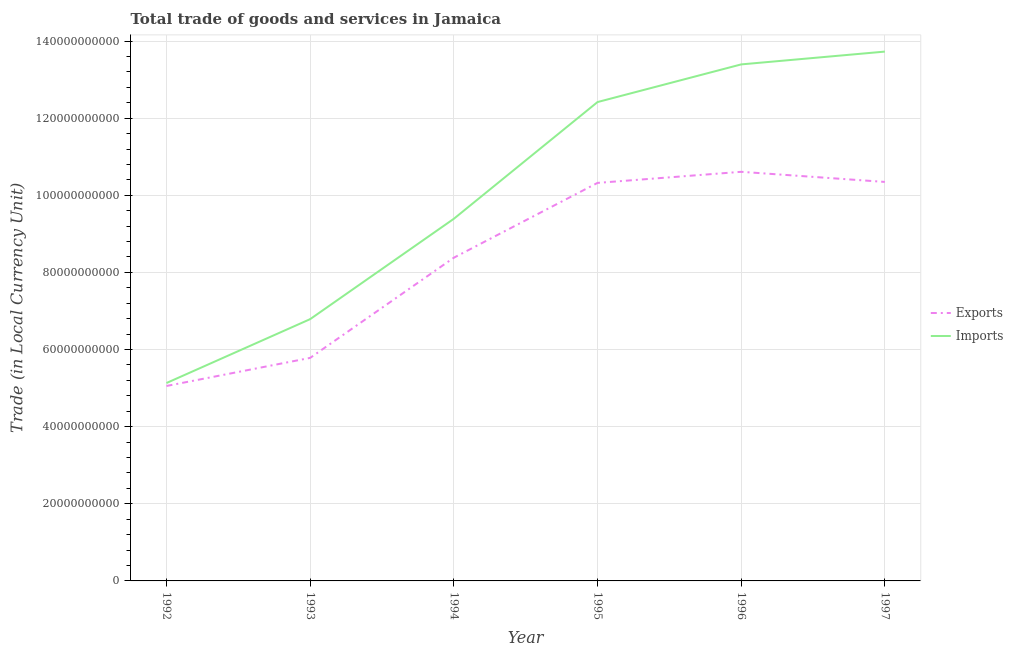How many different coloured lines are there?
Keep it short and to the point. 2. What is the export of goods and services in 1992?
Make the answer very short. 5.06e+1. Across all years, what is the maximum export of goods and services?
Make the answer very short. 1.06e+11. Across all years, what is the minimum imports of goods and services?
Keep it short and to the point. 5.13e+1. What is the total export of goods and services in the graph?
Your response must be concise. 5.05e+11. What is the difference between the export of goods and services in 1994 and that in 1995?
Offer a very short reply. -1.94e+1. What is the difference between the imports of goods and services in 1996 and the export of goods and services in 1992?
Your response must be concise. 8.34e+1. What is the average imports of goods and services per year?
Your response must be concise. 1.01e+11. In the year 1997, what is the difference between the export of goods and services and imports of goods and services?
Ensure brevity in your answer.  -3.38e+1. In how many years, is the imports of goods and services greater than 56000000000 LCU?
Keep it short and to the point. 5. What is the ratio of the export of goods and services in 1992 to that in 1997?
Your answer should be compact. 0.49. Is the export of goods and services in 1993 less than that in 1994?
Your answer should be very brief. Yes. Is the difference between the export of goods and services in 1995 and 1996 greater than the difference between the imports of goods and services in 1995 and 1996?
Make the answer very short. Yes. What is the difference between the highest and the second highest export of goods and services?
Give a very brief answer. 2.62e+09. What is the difference between the highest and the lowest export of goods and services?
Your response must be concise. 5.55e+1. Does the export of goods and services monotonically increase over the years?
Offer a very short reply. No. Is the export of goods and services strictly less than the imports of goods and services over the years?
Your answer should be very brief. Yes. How many lines are there?
Give a very brief answer. 2. Does the graph contain grids?
Your response must be concise. Yes. How many legend labels are there?
Offer a very short reply. 2. What is the title of the graph?
Your answer should be very brief. Total trade of goods and services in Jamaica. What is the label or title of the X-axis?
Offer a terse response. Year. What is the label or title of the Y-axis?
Your answer should be very brief. Trade (in Local Currency Unit). What is the Trade (in Local Currency Unit) in Exports in 1992?
Your answer should be very brief. 5.06e+1. What is the Trade (in Local Currency Unit) in Imports in 1992?
Provide a succinct answer. 5.13e+1. What is the Trade (in Local Currency Unit) in Exports in 1993?
Keep it short and to the point. 5.78e+1. What is the Trade (in Local Currency Unit) in Imports in 1993?
Make the answer very short. 6.79e+1. What is the Trade (in Local Currency Unit) in Exports in 1994?
Keep it short and to the point. 8.38e+1. What is the Trade (in Local Currency Unit) in Imports in 1994?
Make the answer very short. 9.39e+1. What is the Trade (in Local Currency Unit) in Exports in 1995?
Give a very brief answer. 1.03e+11. What is the Trade (in Local Currency Unit) of Imports in 1995?
Keep it short and to the point. 1.24e+11. What is the Trade (in Local Currency Unit) of Exports in 1996?
Give a very brief answer. 1.06e+11. What is the Trade (in Local Currency Unit) of Imports in 1996?
Ensure brevity in your answer.  1.34e+11. What is the Trade (in Local Currency Unit) of Exports in 1997?
Provide a succinct answer. 1.03e+11. What is the Trade (in Local Currency Unit) of Imports in 1997?
Your answer should be compact. 1.37e+11. Across all years, what is the maximum Trade (in Local Currency Unit) of Exports?
Make the answer very short. 1.06e+11. Across all years, what is the maximum Trade (in Local Currency Unit) of Imports?
Ensure brevity in your answer.  1.37e+11. Across all years, what is the minimum Trade (in Local Currency Unit) in Exports?
Provide a succinct answer. 5.06e+1. Across all years, what is the minimum Trade (in Local Currency Unit) of Imports?
Ensure brevity in your answer.  5.13e+1. What is the total Trade (in Local Currency Unit) of Exports in the graph?
Provide a succinct answer. 5.05e+11. What is the total Trade (in Local Currency Unit) in Imports in the graph?
Provide a short and direct response. 6.08e+11. What is the difference between the Trade (in Local Currency Unit) of Exports in 1992 and that in 1993?
Your answer should be compact. -7.28e+09. What is the difference between the Trade (in Local Currency Unit) of Imports in 1992 and that in 1993?
Your answer should be very brief. -1.66e+1. What is the difference between the Trade (in Local Currency Unit) in Exports in 1992 and that in 1994?
Keep it short and to the point. -3.33e+1. What is the difference between the Trade (in Local Currency Unit) in Imports in 1992 and that in 1994?
Provide a succinct answer. -4.26e+1. What is the difference between the Trade (in Local Currency Unit) in Exports in 1992 and that in 1995?
Your answer should be very brief. -5.27e+1. What is the difference between the Trade (in Local Currency Unit) of Imports in 1992 and that in 1995?
Ensure brevity in your answer.  -7.29e+1. What is the difference between the Trade (in Local Currency Unit) in Exports in 1992 and that in 1996?
Provide a short and direct response. -5.55e+1. What is the difference between the Trade (in Local Currency Unit) of Imports in 1992 and that in 1996?
Your response must be concise. -8.26e+1. What is the difference between the Trade (in Local Currency Unit) of Exports in 1992 and that in 1997?
Your answer should be very brief. -5.29e+1. What is the difference between the Trade (in Local Currency Unit) in Imports in 1992 and that in 1997?
Your response must be concise. -8.59e+1. What is the difference between the Trade (in Local Currency Unit) in Exports in 1993 and that in 1994?
Ensure brevity in your answer.  -2.60e+1. What is the difference between the Trade (in Local Currency Unit) of Imports in 1993 and that in 1994?
Your answer should be very brief. -2.60e+1. What is the difference between the Trade (in Local Currency Unit) of Exports in 1993 and that in 1995?
Offer a very short reply. -4.54e+1. What is the difference between the Trade (in Local Currency Unit) of Imports in 1993 and that in 1995?
Offer a terse response. -5.63e+1. What is the difference between the Trade (in Local Currency Unit) of Exports in 1993 and that in 1996?
Offer a very short reply. -4.83e+1. What is the difference between the Trade (in Local Currency Unit) in Imports in 1993 and that in 1996?
Ensure brevity in your answer.  -6.61e+1. What is the difference between the Trade (in Local Currency Unit) of Exports in 1993 and that in 1997?
Your answer should be very brief. -4.56e+1. What is the difference between the Trade (in Local Currency Unit) of Imports in 1993 and that in 1997?
Make the answer very short. -6.94e+1. What is the difference between the Trade (in Local Currency Unit) in Exports in 1994 and that in 1995?
Your answer should be very brief. -1.94e+1. What is the difference between the Trade (in Local Currency Unit) of Imports in 1994 and that in 1995?
Ensure brevity in your answer.  -3.03e+1. What is the difference between the Trade (in Local Currency Unit) in Exports in 1994 and that in 1996?
Your answer should be compact. -2.23e+1. What is the difference between the Trade (in Local Currency Unit) in Imports in 1994 and that in 1996?
Give a very brief answer. -4.00e+1. What is the difference between the Trade (in Local Currency Unit) of Exports in 1994 and that in 1997?
Provide a succinct answer. -1.97e+1. What is the difference between the Trade (in Local Currency Unit) in Imports in 1994 and that in 1997?
Ensure brevity in your answer.  -4.34e+1. What is the difference between the Trade (in Local Currency Unit) in Exports in 1995 and that in 1996?
Ensure brevity in your answer.  -2.88e+09. What is the difference between the Trade (in Local Currency Unit) in Imports in 1995 and that in 1996?
Provide a short and direct response. -9.77e+09. What is the difference between the Trade (in Local Currency Unit) of Exports in 1995 and that in 1997?
Offer a terse response. -2.52e+08. What is the difference between the Trade (in Local Currency Unit) of Imports in 1995 and that in 1997?
Offer a terse response. -1.31e+1. What is the difference between the Trade (in Local Currency Unit) of Exports in 1996 and that in 1997?
Offer a very short reply. 2.62e+09. What is the difference between the Trade (in Local Currency Unit) in Imports in 1996 and that in 1997?
Keep it short and to the point. -3.32e+09. What is the difference between the Trade (in Local Currency Unit) in Exports in 1992 and the Trade (in Local Currency Unit) in Imports in 1993?
Your answer should be compact. -1.73e+1. What is the difference between the Trade (in Local Currency Unit) of Exports in 1992 and the Trade (in Local Currency Unit) of Imports in 1994?
Give a very brief answer. -4.34e+1. What is the difference between the Trade (in Local Currency Unit) of Exports in 1992 and the Trade (in Local Currency Unit) of Imports in 1995?
Your answer should be very brief. -7.36e+1. What is the difference between the Trade (in Local Currency Unit) of Exports in 1992 and the Trade (in Local Currency Unit) of Imports in 1996?
Keep it short and to the point. -8.34e+1. What is the difference between the Trade (in Local Currency Unit) of Exports in 1992 and the Trade (in Local Currency Unit) of Imports in 1997?
Offer a very short reply. -8.67e+1. What is the difference between the Trade (in Local Currency Unit) in Exports in 1993 and the Trade (in Local Currency Unit) in Imports in 1994?
Make the answer very short. -3.61e+1. What is the difference between the Trade (in Local Currency Unit) in Exports in 1993 and the Trade (in Local Currency Unit) in Imports in 1995?
Ensure brevity in your answer.  -6.63e+1. What is the difference between the Trade (in Local Currency Unit) in Exports in 1993 and the Trade (in Local Currency Unit) in Imports in 1996?
Your answer should be compact. -7.61e+1. What is the difference between the Trade (in Local Currency Unit) in Exports in 1993 and the Trade (in Local Currency Unit) in Imports in 1997?
Offer a terse response. -7.94e+1. What is the difference between the Trade (in Local Currency Unit) of Exports in 1994 and the Trade (in Local Currency Unit) of Imports in 1995?
Provide a succinct answer. -4.04e+1. What is the difference between the Trade (in Local Currency Unit) in Exports in 1994 and the Trade (in Local Currency Unit) in Imports in 1996?
Give a very brief answer. -5.01e+1. What is the difference between the Trade (in Local Currency Unit) of Exports in 1994 and the Trade (in Local Currency Unit) of Imports in 1997?
Offer a terse response. -5.34e+1. What is the difference between the Trade (in Local Currency Unit) of Exports in 1995 and the Trade (in Local Currency Unit) of Imports in 1996?
Your answer should be very brief. -3.07e+1. What is the difference between the Trade (in Local Currency Unit) in Exports in 1995 and the Trade (in Local Currency Unit) in Imports in 1997?
Offer a very short reply. -3.40e+1. What is the difference between the Trade (in Local Currency Unit) of Exports in 1996 and the Trade (in Local Currency Unit) of Imports in 1997?
Your answer should be compact. -3.12e+1. What is the average Trade (in Local Currency Unit) of Exports per year?
Make the answer very short. 8.42e+1. What is the average Trade (in Local Currency Unit) of Imports per year?
Provide a short and direct response. 1.01e+11. In the year 1992, what is the difference between the Trade (in Local Currency Unit) in Exports and Trade (in Local Currency Unit) in Imports?
Provide a short and direct response. -7.67e+08. In the year 1993, what is the difference between the Trade (in Local Currency Unit) of Exports and Trade (in Local Currency Unit) of Imports?
Your answer should be compact. -1.00e+1. In the year 1994, what is the difference between the Trade (in Local Currency Unit) in Exports and Trade (in Local Currency Unit) in Imports?
Your response must be concise. -1.01e+1. In the year 1995, what is the difference between the Trade (in Local Currency Unit) in Exports and Trade (in Local Currency Unit) in Imports?
Keep it short and to the point. -2.10e+1. In the year 1996, what is the difference between the Trade (in Local Currency Unit) in Exports and Trade (in Local Currency Unit) in Imports?
Keep it short and to the point. -2.79e+1. In the year 1997, what is the difference between the Trade (in Local Currency Unit) in Exports and Trade (in Local Currency Unit) in Imports?
Give a very brief answer. -3.38e+1. What is the ratio of the Trade (in Local Currency Unit) of Exports in 1992 to that in 1993?
Provide a succinct answer. 0.87. What is the ratio of the Trade (in Local Currency Unit) of Imports in 1992 to that in 1993?
Provide a short and direct response. 0.76. What is the ratio of the Trade (in Local Currency Unit) of Exports in 1992 to that in 1994?
Your answer should be very brief. 0.6. What is the ratio of the Trade (in Local Currency Unit) of Imports in 1992 to that in 1994?
Your response must be concise. 0.55. What is the ratio of the Trade (in Local Currency Unit) of Exports in 1992 to that in 1995?
Offer a terse response. 0.49. What is the ratio of the Trade (in Local Currency Unit) of Imports in 1992 to that in 1995?
Provide a succinct answer. 0.41. What is the ratio of the Trade (in Local Currency Unit) in Exports in 1992 to that in 1996?
Give a very brief answer. 0.48. What is the ratio of the Trade (in Local Currency Unit) of Imports in 1992 to that in 1996?
Make the answer very short. 0.38. What is the ratio of the Trade (in Local Currency Unit) of Exports in 1992 to that in 1997?
Your answer should be very brief. 0.49. What is the ratio of the Trade (in Local Currency Unit) in Imports in 1992 to that in 1997?
Provide a short and direct response. 0.37. What is the ratio of the Trade (in Local Currency Unit) of Exports in 1993 to that in 1994?
Provide a short and direct response. 0.69. What is the ratio of the Trade (in Local Currency Unit) in Imports in 1993 to that in 1994?
Your answer should be very brief. 0.72. What is the ratio of the Trade (in Local Currency Unit) in Exports in 1993 to that in 1995?
Give a very brief answer. 0.56. What is the ratio of the Trade (in Local Currency Unit) in Imports in 1993 to that in 1995?
Your answer should be very brief. 0.55. What is the ratio of the Trade (in Local Currency Unit) in Exports in 1993 to that in 1996?
Provide a short and direct response. 0.55. What is the ratio of the Trade (in Local Currency Unit) in Imports in 1993 to that in 1996?
Your answer should be compact. 0.51. What is the ratio of the Trade (in Local Currency Unit) of Exports in 1993 to that in 1997?
Give a very brief answer. 0.56. What is the ratio of the Trade (in Local Currency Unit) of Imports in 1993 to that in 1997?
Provide a succinct answer. 0.49. What is the ratio of the Trade (in Local Currency Unit) in Exports in 1994 to that in 1995?
Provide a succinct answer. 0.81. What is the ratio of the Trade (in Local Currency Unit) in Imports in 1994 to that in 1995?
Provide a short and direct response. 0.76. What is the ratio of the Trade (in Local Currency Unit) in Exports in 1994 to that in 1996?
Offer a very short reply. 0.79. What is the ratio of the Trade (in Local Currency Unit) in Imports in 1994 to that in 1996?
Provide a succinct answer. 0.7. What is the ratio of the Trade (in Local Currency Unit) in Exports in 1994 to that in 1997?
Provide a succinct answer. 0.81. What is the ratio of the Trade (in Local Currency Unit) in Imports in 1994 to that in 1997?
Provide a short and direct response. 0.68. What is the ratio of the Trade (in Local Currency Unit) in Exports in 1995 to that in 1996?
Provide a short and direct response. 0.97. What is the ratio of the Trade (in Local Currency Unit) in Imports in 1995 to that in 1996?
Offer a very short reply. 0.93. What is the ratio of the Trade (in Local Currency Unit) of Imports in 1995 to that in 1997?
Make the answer very short. 0.9. What is the ratio of the Trade (in Local Currency Unit) of Exports in 1996 to that in 1997?
Ensure brevity in your answer.  1.03. What is the ratio of the Trade (in Local Currency Unit) in Imports in 1996 to that in 1997?
Your answer should be compact. 0.98. What is the difference between the highest and the second highest Trade (in Local Currency Unit) of Exports?
Your answer should be compact. 2.62e+09. What is the difference between the highest and the second highest Trade (in Local Currency Unit) in Imports?
Provide a succinct answer. 3.32e+09. What is the difference between the highest and the lowest Trade (in Local Currency Unit) in Exports?
Provide a short and direct response. 5.55e+1. What is the difference between the highest and the lowest Trade (in Local Currency Unit) of Imports?
Ensure brevity in your answer.  8.59e+1. 